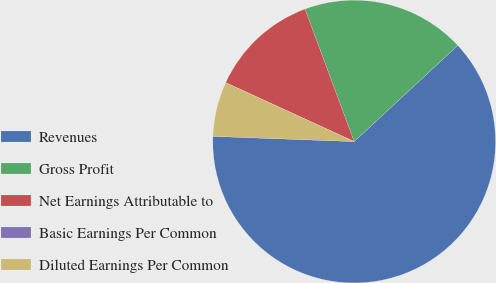Convert chart to OTSL. <chart><loc_0><loc_0><loc_500><loc_500><pie_chart><fcel>Revenues<fcel>Gross Profit<fcel>Net Earnings Attributable to<fcel>Basic Earnings Per Common<fcel>Diluted Earnings Per Common<nl><fcel>62.5%<fcel>18.75%<fcel>12.5%<fcel>0.0%<fcel>6.25%<nl></chart> 